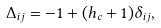Convert formula to latex. <formula><loc_0><loc_0><loc_500><loc_500>\Delta _ { i j } = - 1 + ( h _ { c } + 1 ) \delta _ { i j } ,</formula> 